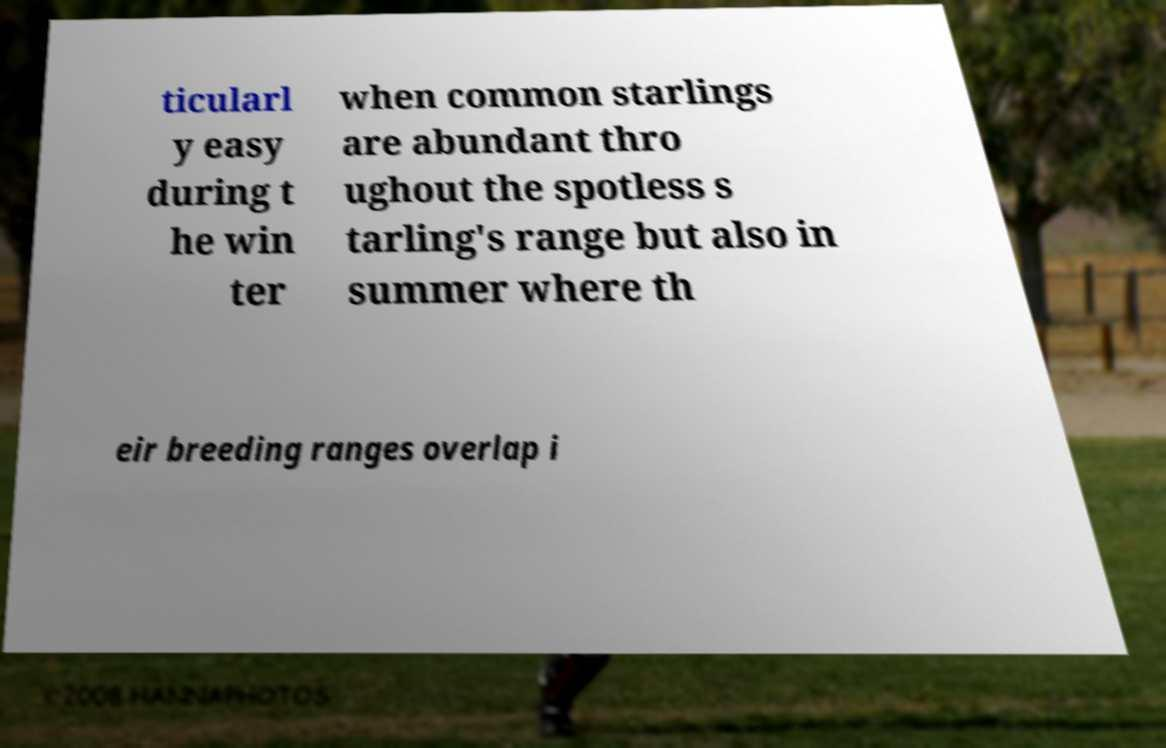For documentation purposes, I need the text within this image transcribed. Could you provide that? ticularl y easy during t he win ter when common starlings are abundant thro ughout the spotless s tarling's range but also in summer where th eir breeding ranges overlap i 